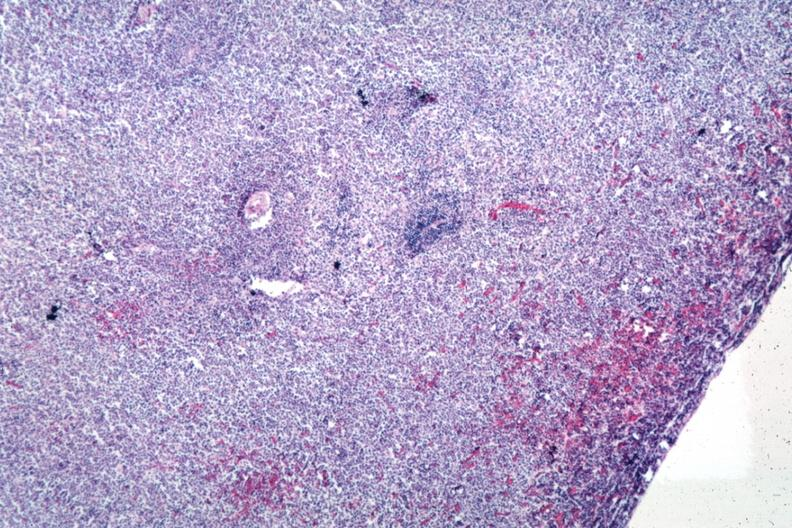s spleen present?
Answer the question using a single word or phrase. Yes 